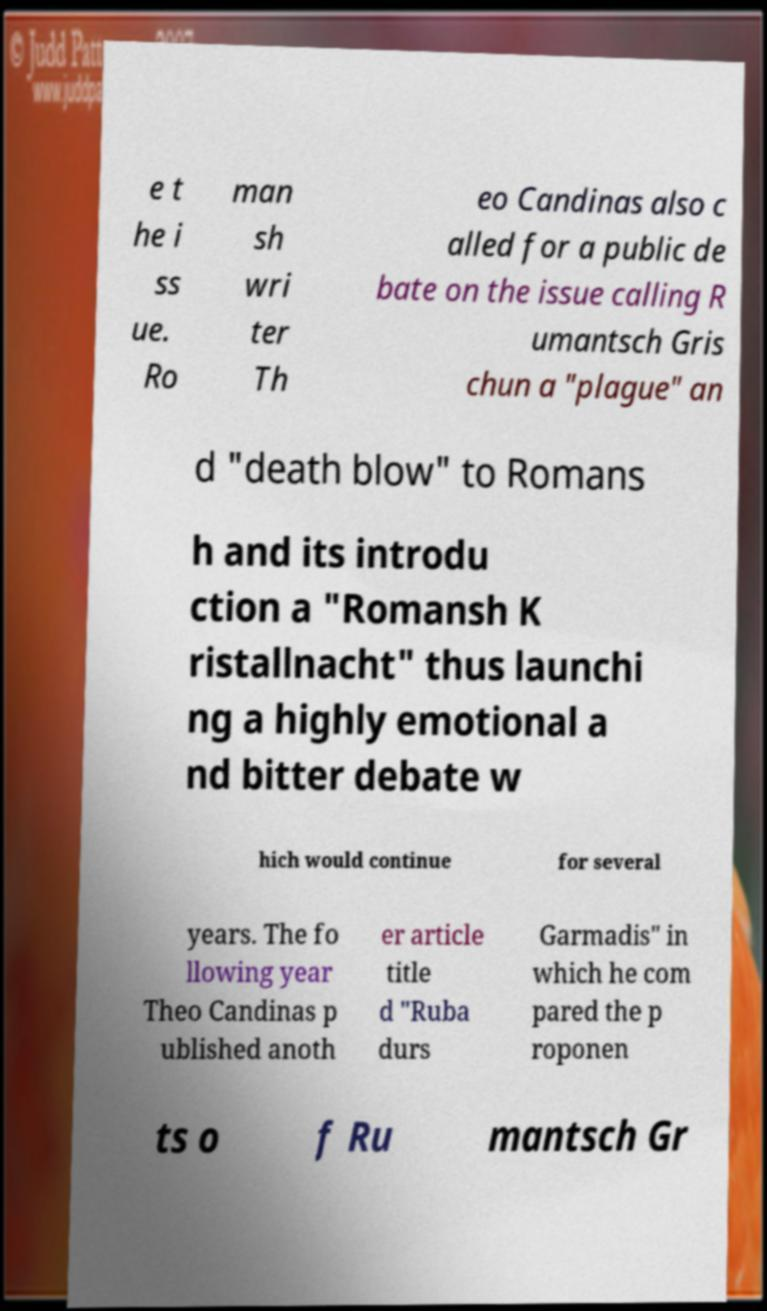Can you accurately transcribe the text from the provided image for me? e t he i ss ue. Ro man sh wri ter Th eo Candinas also c alled for a public de bate on the issue calling R umantsch Gris chun a "plague" an d "death blow" to Romans h and its introdu ction a "Romansh K ristallnacht" thus launchi ng a highly emotional a nd bitter debate w hich would continue for several years. The fo llowing year Theo Candinas p ublished anoth er article title d "Ruba durs Garmadis" in which he com pared the p roponen ts o f Ru mantsch Gr 